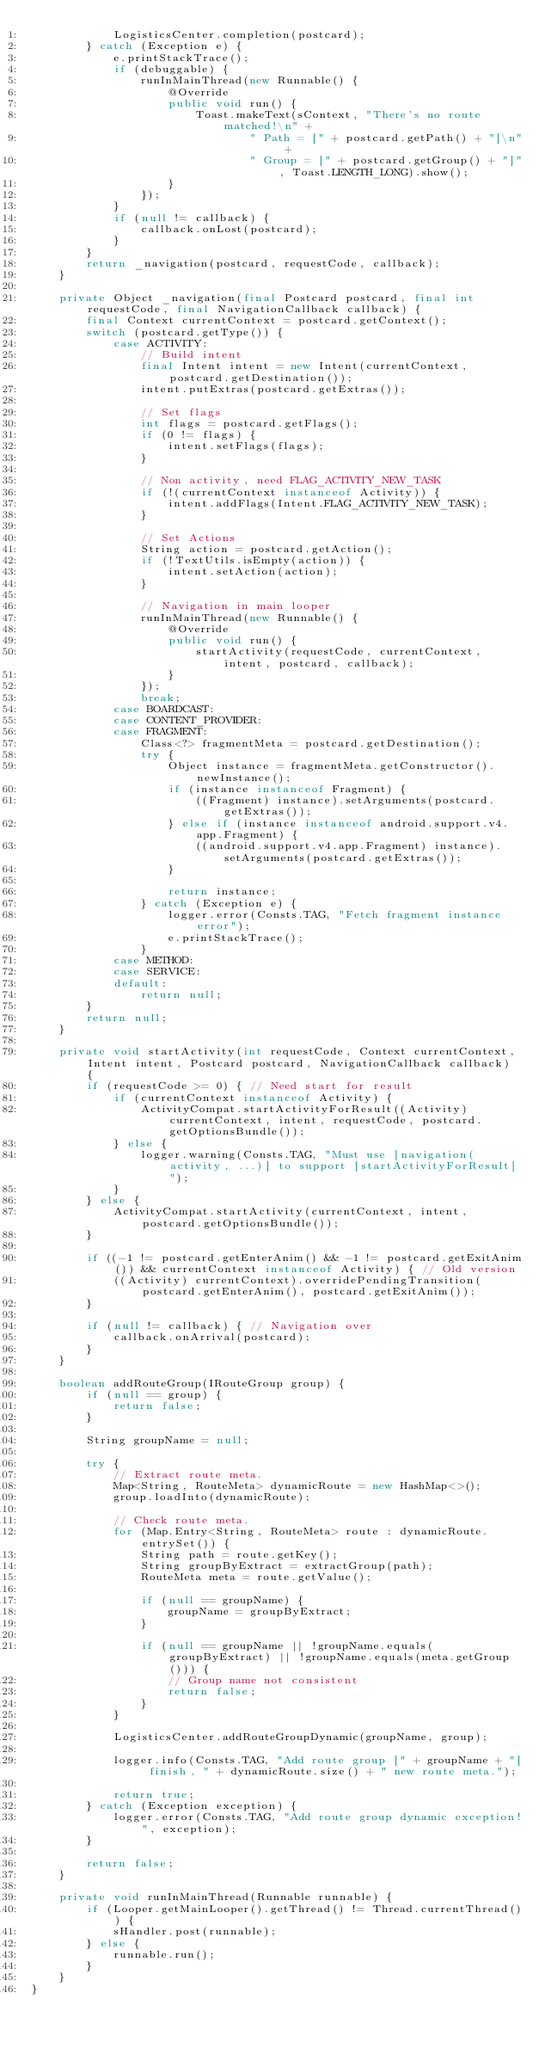Convert code to text. <code><loc_0><loc_0><loc_500><loc_500><_Java_>            LogisticsCenter.completion(postcard);
        } catch (Exception e) {
            e.printStackTrace();
            if (debuggable) {
                runInMainThread(new Runnable() {
                    @Override
                    public void run() {
                        Toast.makeText(sContext, "There's no route matched!\n" +
                                " Path = [" + postcard.getPath() + "]\n" +
                                " Group = [" + postcard.getGroup() + "]", Toast.LENGTH_LONG).show();
                    }
                });
            }
            if (null != callback) {
                callback.onLost(postcard);
            }
        }
        return _navigation(postcard, requestCode, callback);
    }

    private Object _navigation(final Postcard postcard, final int requestCode, final NavigationCallback callback) {
        final Context currentContext = postcard.getContext();
        switch (postcard.getType()) {
            case ACTIVITY:
                // Build intent
                final Intent intent = new Intent(currentContext, postcard.getDestination());
                intent.putExtras(postcard.getExtras());

                // Set flags
                int flags = postcard.getFlags();
                if (0 != flags) {
                    intent.setFlags(flags);
                }

                // Non activity, need FLAG_ACTIVITY_NEW_TASK
                if (!(currentContext instanceof Activity)) {
                    intent.addFlags(Intent.FLAG_ACTIVITY_NEW_TASK);
                }

                // Set Actions
                String action = postcard.getAction();
                if (!TextUtils.isEmpty(action)) {
                    intent.setAction(action);
                }

                // Navigation in main looper
                runInMainThread(new Runnable() {
                    @Override
                    public void run() {
                        startActivity(requestCode, currentContext, intent, postcard, callback);
                    }
                });
                break;
            case BOARDCAST:
            case CONTENT_PROVIDER:
            case FRAGMENT:
                Class<?> fragmentMeta = postcard.getDestination();
                try {
                    Object instance = fragmentMeta.getConstructor().newInstance();
                    if (instance instanceof Fragment) {
                        ((Fragment) instance).setArguments(postcard.getExtras());
                    } else if (instance instanceof android.support.v4.app.Fragment) {
                        ((android.support.v4.app.Fragment) instance).setArguments(postcard.getExtras());
                    }

                    return instance;
                } catch (Exception e) {
                    logger.error(Consts.TAG, "Fetch fragment instance error");
                    e.printStackTrace();
                }
            case METHOD:
            case SERVICE:
            default:
                return null;
        }
        return null;
    }

    private void startActivity(int requestCode, Context currentContext, Intent intent, Postcard postcard, NavigationCallback callback) {
        if (requestCode >= 0) { // Need start for result
            if (currentContext instanceof Activity) {
                ActivityCompat.startActivityForResult((Activity) currentContext, intent, requestCode, postcard.getOptionsBundle());
            } else {
                logger.warning(Consts.TAG, "Must use [navigation(activity, ...)] to support [startActivityForResult]");
            }
        } else {
            ActivityCompat.startActivity(currentContext, intent, postcard.getOptionsBundle());
        }

        if ((-1 != postcard.getEnterAnim() && -1 != postcard.getExitAnim()) && currentContext instanceof Activity) { // Old version
            ((Activity) currentContext).overridePendingTransition(postcard.getEnterAnim(), postcard.getExitAnim());
        }

        if (null != callback) { // Navigation over
            callback.onArrival(postcard);
        }
    }

    boolean addRouteGroup(IRouteGroup group) {
        if (null == group) {
            return false;
        }

        String groupName = null;

        try {
            // Extract route meta.
            Map<String, RouteMeta> dynamicRoute = new HashMap<>();
            group.loadInto(dynamicRoute);

            // Check route meta.
            for (Map.Entry<String, RouteMeta> route : dynamicRoute.entrySet()) {
                String path = route.getKey();
                String groupByExtract = extractGroup(path);
                RouteMeta meta = route.getValue();

                if (null == groupName) {
                    groupName = groupByExtract;
                }

                if (null == groupName || !groupName.equals(groupByExtract) || !groupName.equals(meta.getGroup())) {
                    // Group name not consistent
                    return false;
                }
            }

            LogisticsCenter.addRouteGroupDynamic(groupName, group);

            logger.info(Consts.TAG, "Add route group [" + groupName + "] finish, " + dynamicRoute.size() + " new route meta.");

            return true;
        } catch (Exception exception) {
            logger.error(Consts.TAG, "Add route group dynamic exception!", exception);
        }

        return false;
    }

    private void runInMainThread(Runnable runnable) {
        if (Looper.getMainLooper().getThread() != Thread.currentThread()) {
            sHandler.post(runnable);
        } else {
            runnable.run();
        }
    }
}
</code> 